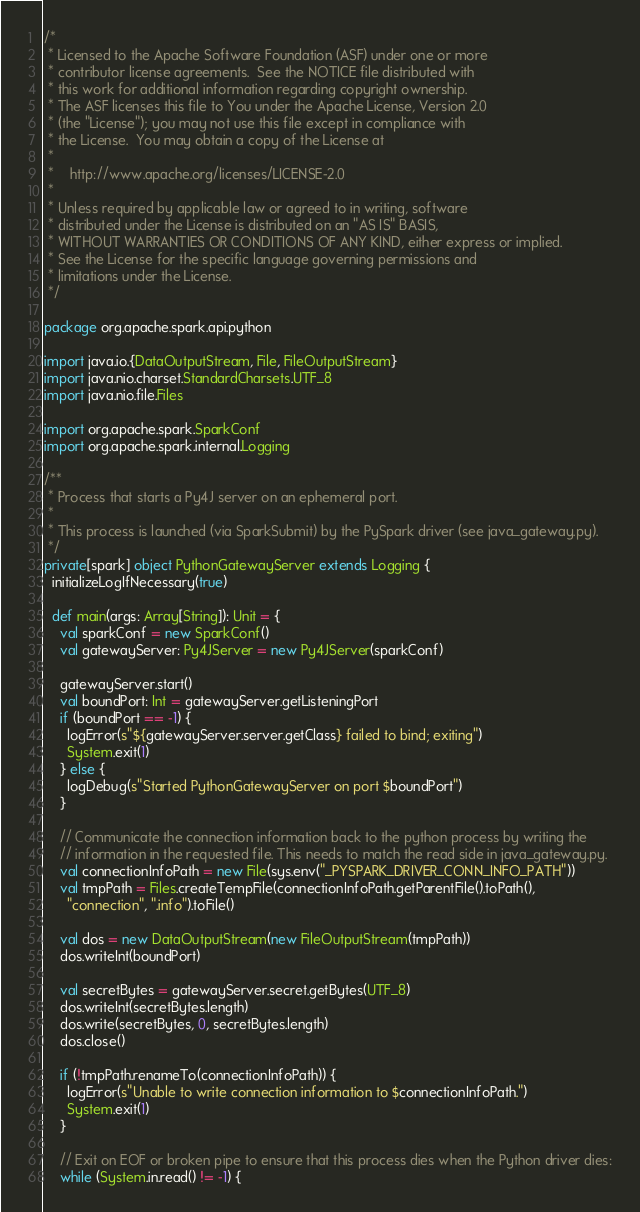<code> <loc_0><loc_0><loc_500><loc_500><_Scala_>/*
 * Licensed to the Apache Software Foundation (ASF) under one or more
 * contributor license agreements.  See the NOTICE file distributed with
 * this work for additional information regarding copyright ownership.
 * The ASF licenses this file to You under the Apache License, Version 2.0
 * (the "License"); you may not use this file except in compliance with
 * the License.  You may obtain a copy of the License at
 *
 *    http://www.apache.org/licenses/LICENSE-2.0
 *
 * Unless required by applicable law or agreed to in writing, software
 * distributed under the License is distributed on an "AS IS" BASIS,
 * WITHOUT WARRANTIES OR CONDITIONS OF ANY KIND, either express or implied.
 * See the License for the specific language governing permissions and
 * limitations under the License.
 */

package org.apache.spark.api.python

import java.io.{DataOutputStream, File, FileOutputStream}
import java.nio.charset.StandardCharsets.UTF_8
import java.nio.file.Files

import org.apache.spark.SparkConf
import org.apache.spark.internal.Logging

/**
 * Process that starts a Py4J server on an ephemeral port.
 *
 * This process is launched (via SparkSubmit) by the PySpark driver (see java_gateway.py).
 */
private[spark] object PythonGatewayServer extends Logging {
  initializeLogIfNecessary(true)

  def main(args: Array[String]): Unit = {
    val sparkConf = new SparkConf()
    val gatewayServer: Py4JServer = new Py4JServer(sparkConf)

    gatewayServer.start()
    val boundPort: Int = gatewayServer.getListeningPort
    if (boundPort == -1) {
      logError(s"${gatewayServer.server.getClass} failed to bind; exiting")
      System.exit(1)
    } else {
      logDebug(s"Started PythonGatewayServer on port $boundPort")
    }

    // Communicate the connection information back to the python process by writing the
    // information in the requested file. This needs to match the read side in java_gateway.py.
    val connectionInfoPath = new File(sys.env("_PYSPARK_DRIVER_CONN_INFO_PATH"))
    val tmpPath = Files.createTempFile(connectionInfoPath.getParentFile().toPath(),
      "connection", ".info").toFile()

    val dos = new DataOutputStream(new FileOutputStream(tmpPath))
    dos.writeInt(boundPort)

    val secretBytes = gatewayServer.secret.getBytes(UTF_8)
    dos.writeInt(secretBytes.length)
    dos.write(secretBytes, 0, secretBytes.length)
    dos.close()

    if (!tmpPath.renameTo(connectionInfoPath)) {
      logError(s"Unable to write connection information to $connectionInfoPath.")
      System.exit(1)
    }

    // Exit on EOF or broken pipe to ensure that this process dies when the Python driver dies:
    while (System.in.read() != -1) {</code> 